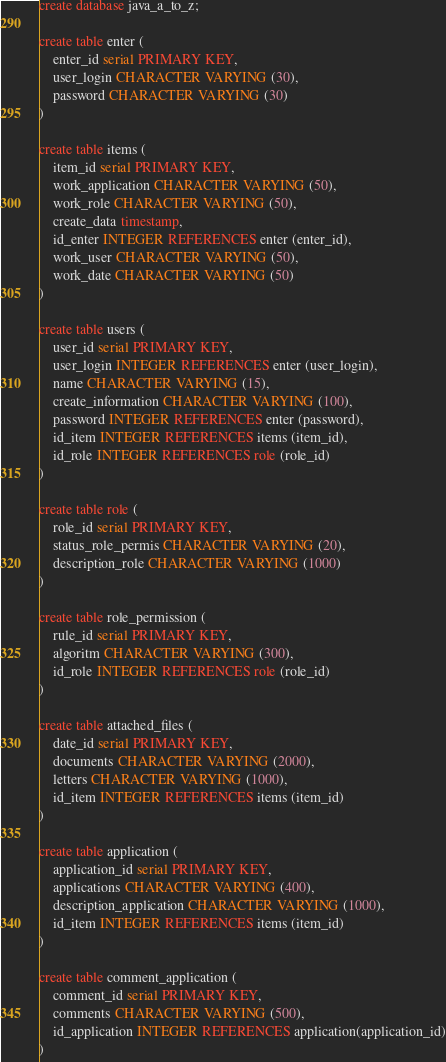<code> <loc_0><loc_0><loc_500><loc_500><_SQL_>create database java_a_to_z;

create table enter (
	enter_id serial PRIMARY KEY,
	user_login CHARACTER VARYING (30),
	password CHARACTER VARYING (30)
)

create table items (
	item_id serial PRIMARY KEY,
	work_application CHARACTER VARYING (50),
	work_role CHARACTER VARYING (50),
	create_data timestamp,
	id_enter INTEGER REFERENCES enter (enter_id),
	work_user CHARACTER VARYING (50),
	work_date CHARACTER VARYING (50)
)

create table users (
	user_id serial PRIMARY KEY,
	user_login INTEGER REFERENCES enter (user_login), 
	name CHARACTER VARYING (15),
	create_information CHARACTER VARYING (100),
	password INTEGER REFERENCES enter (password),
	id_item INTEGER REFERENCES items (item_id),
	id_role INTEGER REFERENCES role (role_id)
)

create table role (
	role_id serial PRIMARY KEY,
	status_role_permis CHARACTER VARYING (20),
	description_role CHARACTER VARYING (1000)
)

create table role_permission (
	rule_id serial PRIMARY KEY,
	algoritm CHARACTER VARYING (300),
	id_role INTEGER REFERENCES role (role_id)
)

create table attached_files (
	date_id serial PRIMARY KEY,
	documents CHARACTER VARYING (2000),
	letters CHARACTER VARYING (1000),
	id_item INTEGER REFERENCES items (item_id)
)

create table application (
	application_id serial PRIMARY KEY,
	applications CHARACTER VARYING (400),
	description_application CHARACTER VARYING (1000),
	id_item INTEGER REFERENCES items (item_id)
)

create table comment_application (
	comment_id serial PRIMARY KEY,
	comments CHARACTER VARYING (500),
	id_application INTEGER REFERENCES application(application_id)
)</code> 